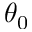Convert formula to latex. <formula><loc_0><loc_0><loc_500><loc_500>\theta _ { 0 }</formula> 